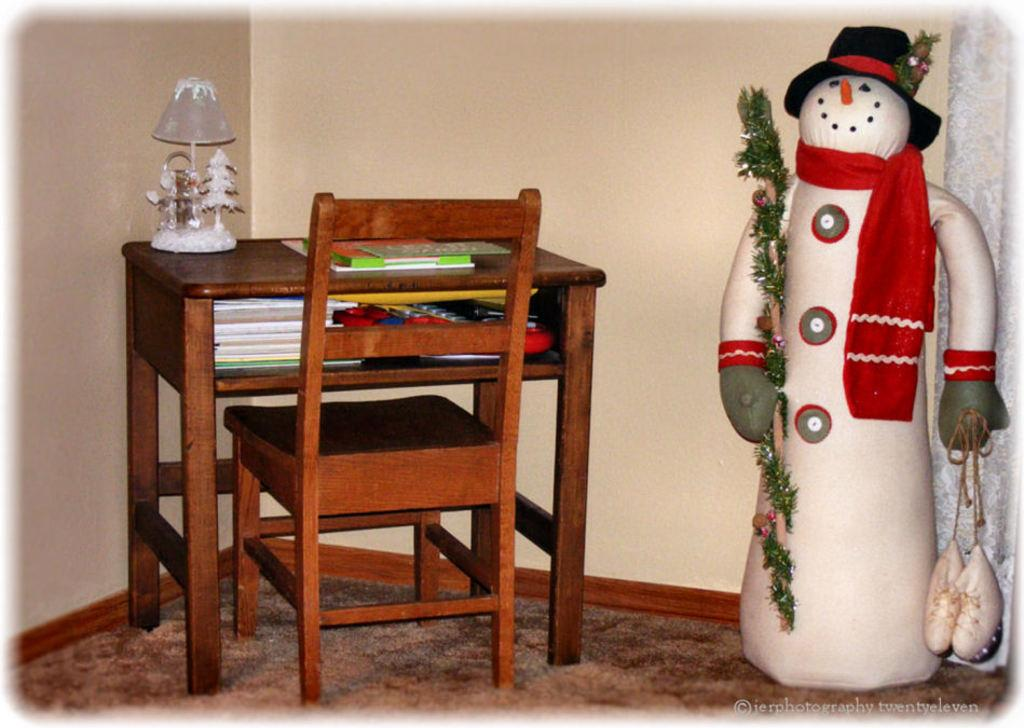What type of furniture is present in the image? There is a chair and a table in the image. What items can be seen on the table? There are books, a toy, a cap, and shoes on the table. What is visible in the background of the image? There is a wall and a curtain in the background of the image. What type of wound can be seen on the body of the person in the image? There is no person present in the image, and therefore no wound can be observed. 